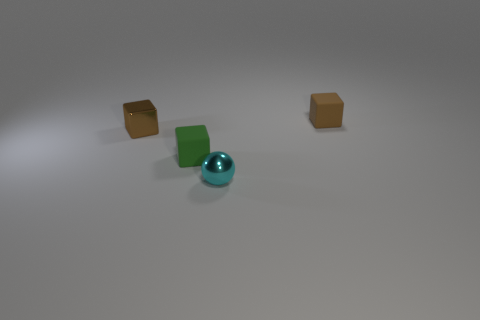Subtract all green rubber blocks. How many blocks are left? 2 Add 1 tiny things. How many objects exist? 5 Subtract all purple balls. How many brown cubes are left? 2 Subtract 1 blocks. How many blocks are left? 2 Subtract all balls. How many objects are left? 3 Add 3 large brown matte balls. How many large brown matte balls exist? 3 Subtract 0 gray cubes. How many objects are left? 4 Subtract all tiny green things. Subtract all metal cubes. How many objects are left? 2 Add 3 cubes. How many cubes are left? 6 